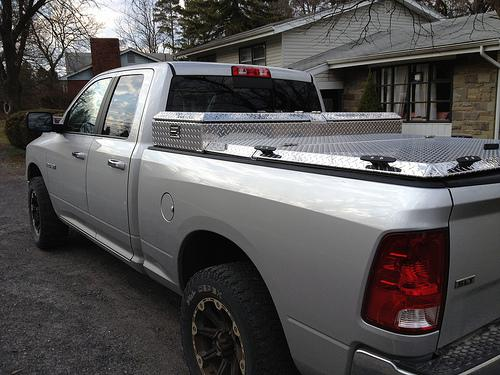Question: where is the truck parked?
Choices:
A. In a metered space.
B. In a parking garage.
C. On the ferry.
D. The driveway.
Answer with the letter. Answer: D Question: what day of the week is it?
Choices:
A. Tuesday.
B. Sunday.
C. Monday.
D. Friday.
Answer with the letter. Answer: C Question: what color is the truck?
Choices:
A. Gold.
B. Grey.
C. White.
D. Silver.
Answer with the letter. Answer: D 